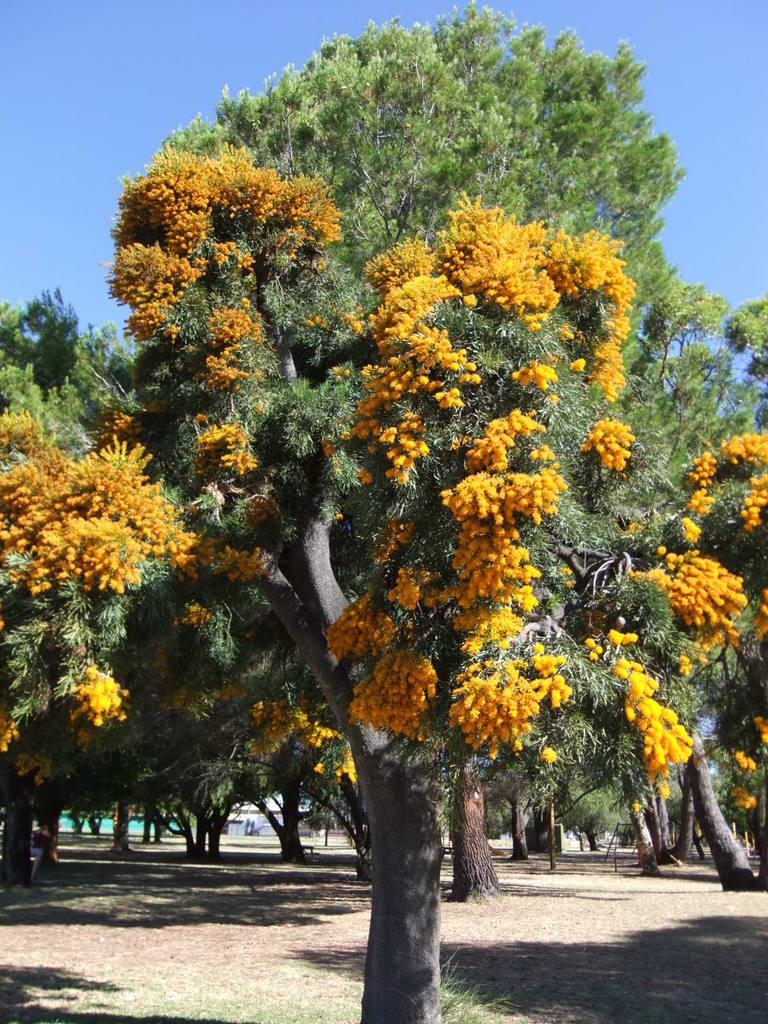What type of vegetation can be seen in the image? There are trees in the image. What is visible behind the trees in the image? The sky is visible behind the trees in the image. What type of soap is being used to clean the trees in the image? There is no soap or cleaning activity present in the image; it simply shows trees and the sky. 